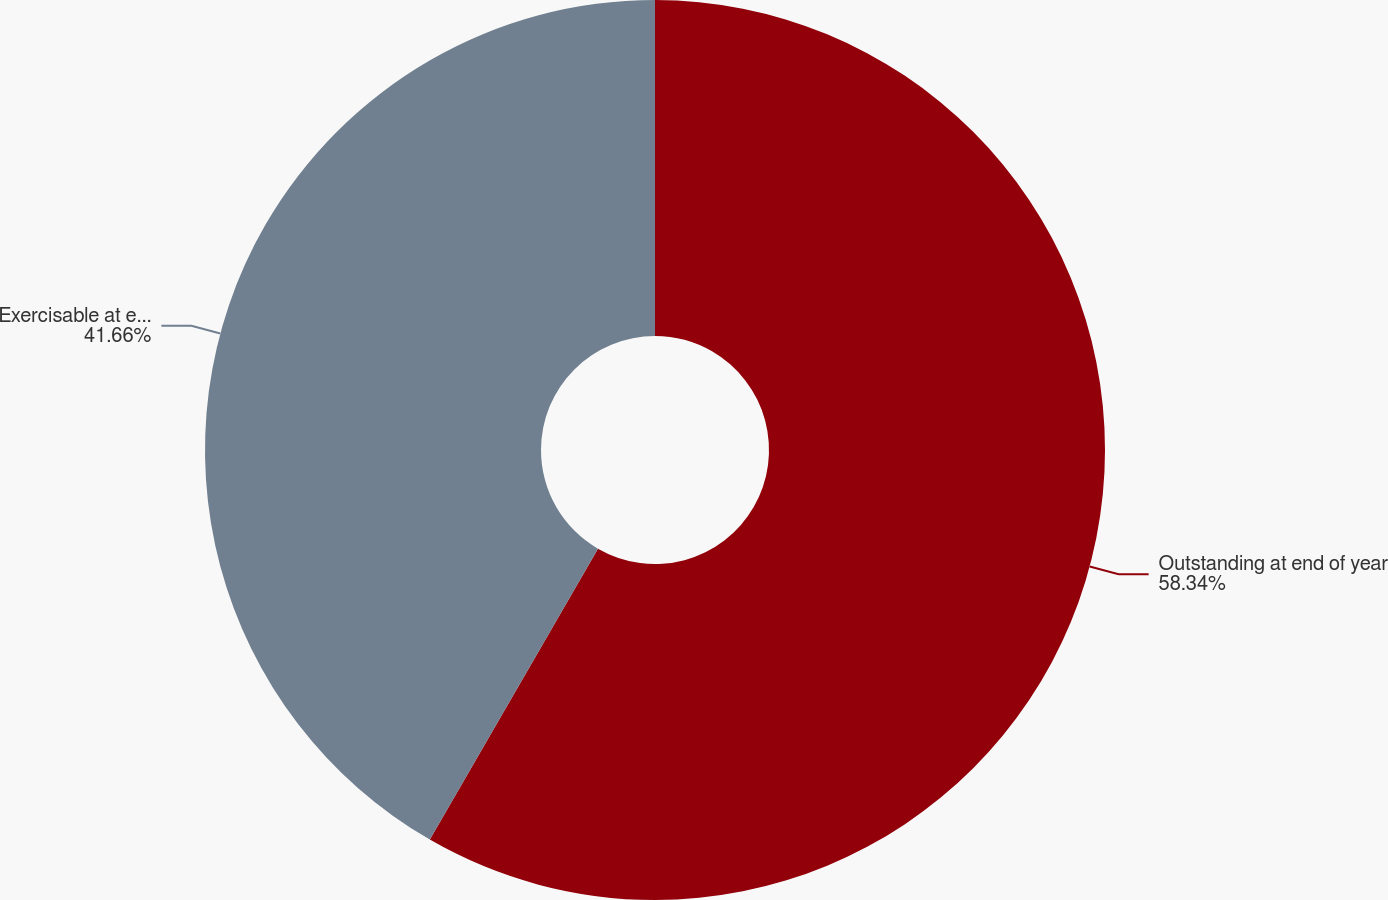<chart> <loc_0><loc_0><loc_500><loc_500><pie_chart><fcel>Outstanding at end of year<fcel>Exercisable at end of year<nl><fcel>58.34%<fcel>41.66%<nl></chart> 